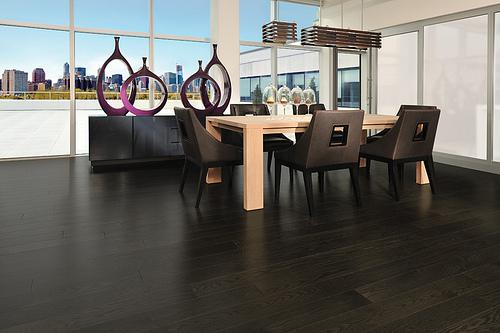Question: what is the color of the chair?
Choices:
A. Black.
B. Red.
C. Blue.
D. White.
Answer with the letter. Answer: A Question: how are the chair arranged?
Choices:
A. Around the table.
B. In a row.
C. In a circle.
D. In a square.
Answer with the letter. Answer: A Question: what is the color of the sky?
Choices:
A. Blue.
B. Grey.
C. Black.
D. Aqua.
Answer with the letter. Answer: A 